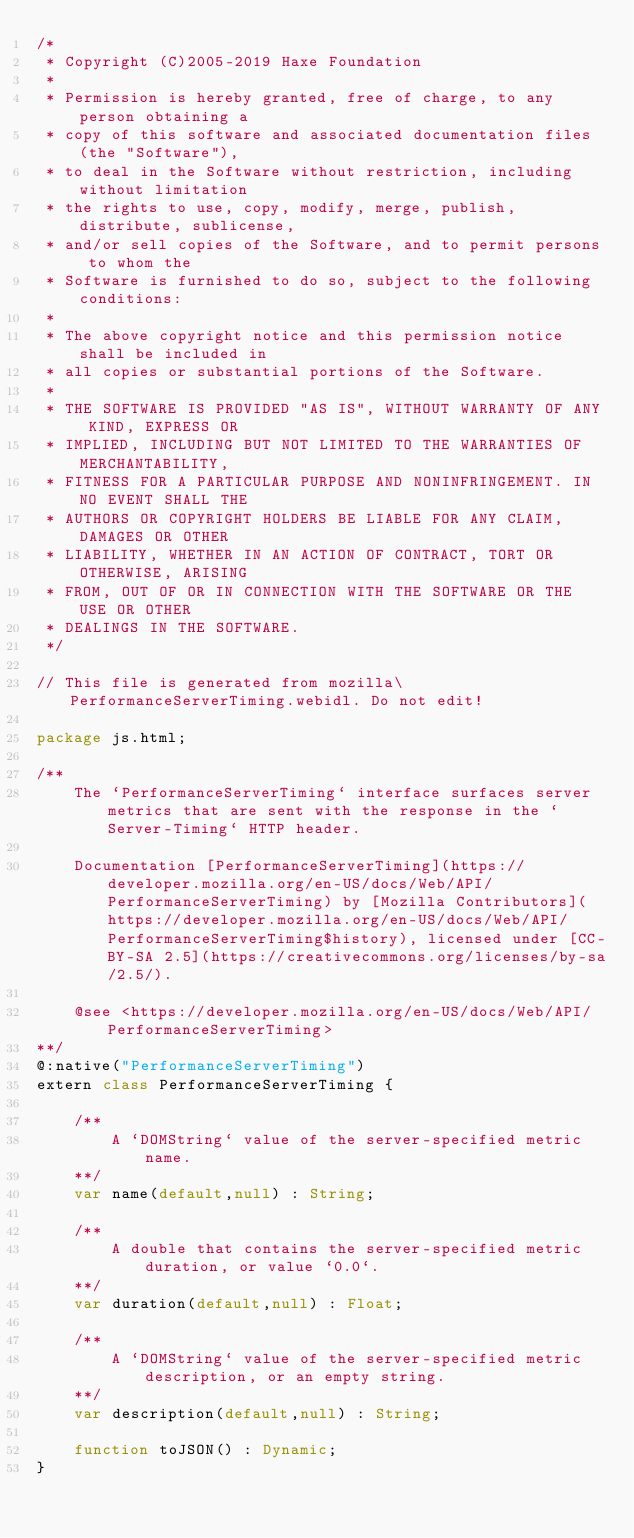Convert code to text. <code><loc_0><loc_0><loc_500><loc_500><_Haxe_>/*
 * Copyright (C)2005-2019 Haxe Foundation
 *
 * Permission is hereby granted, free of charge, to any person obtaining a
 * copy of this software and associated documentation files (the "Software"),
 * to deal in the Software without restriction, including without limitation
 * the rights to use, copy, modify, merge, publish, distribute, sublicense,
 * and/or sell copies of the Software, and to permit persons to whom the
 * Software is furnished to do so, subject to the following conditions:
 *
 * The above copyright notice and this permission notice shall be included in
 * all copies or substantial portions of the Software.
 *
 * THE SOFTWARE IS PROVIDED "AS IS", WITHOUT WARRANTY OF ANY KIND, EXPRESS OR
 * IMPLIED, INCLUDING BUT NOT LIMITED TO THE WARRANTIES OF MERCHANTABILITY,
 * FITNESS FOR A PARTICULAR PURPOSE AND NONINFRINGEMENT. IN NO EVENT SHALL THE
 * AUTHORS OR COPYRIGHT HOLDERS BE LIABLE FOR ANY CLAIM, DAMAGES OR OTHER
 * LIABILITY, WHETHER IN AN ACTION OF CONTRACT, TORT OR OTHERWISE, ARISING
 * FROM, OUT OF OR IN CONNECTION WITH THE SOFTWARE OR THE USE OR OTHER
 * DEALINGS IN THE SOFTWARE.
 */

// This file is generated from mozilla\PerformanceServerTiming.webidl. Do not edit!

package js.html;

/**
	The `PerformanceServerTiming` interface surfaces server metrics that are sent with the response in the `Server-Timing` HTTP header.

	Documentation [PerformanceServerTiming](https://developer.mozilla.org/en-US/docs/Web/API/PerformanceServerTiming) by [Mozilla Contributors](https://developer.mozilla.org/en-US/docs/Web/API/PerformanceServerTiming$history), licensed under [CC-BY-SA 2.5](https://creativecommons.org/licenses/by-sa/2.5/).

	@see <https://developer.mozilla.org/en-US/docs/Web/API/PerformanceServerTiming>
**/
@:native("PerformanceServerTiming")
extern class PerformanceServerTiming {
	
	/**
		A `DOMString` value of the server-specified metric name.
	**/
	var name(default,null) : String;
	
	/**
		A double that contains the server-specified metric duration, or value `0.0`.
	**/
	var duration(default,null) : Float;
	
	/**
		A `DOMString` value of the server-specified metric description, or an empty string.
	**/
	var description(default,null) : String;
	
	function toJSON() : Dynamic;
}</code> 